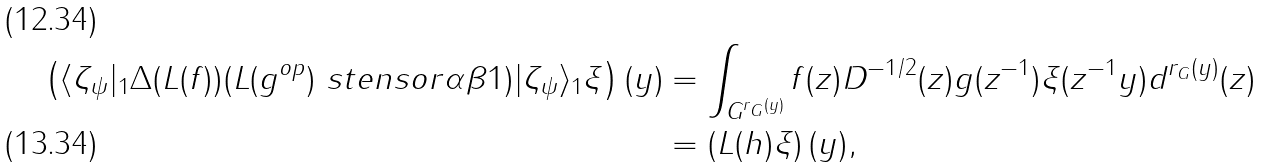Convert formula to latex. <formula><loc_0><loc_0><loc_500><loc_500>\left ( \langle \zeta _ { \psi } | _ { 1 } \Delta ( L ( f ) ) ( L ( g ^ { o p } ) \ s t e n s o r { \alpha } { \beta } 1 ) | \zeta _ { \psi } \rangle _ { 1 } \xi \right ) ( y ) & = \int _ { G ^ { r _ { G } ( y ) } } f ( z ) D ^ { - 1 / 2 } ( z ) g ( z ^ { - 1 } ) \xi ( z ^ { - 1 } y ) d ^ { r _ { G } ( y ) } ( z ) \\ & = \left ( L ( h ) \xi \right ) ( y ) ,</formula> 